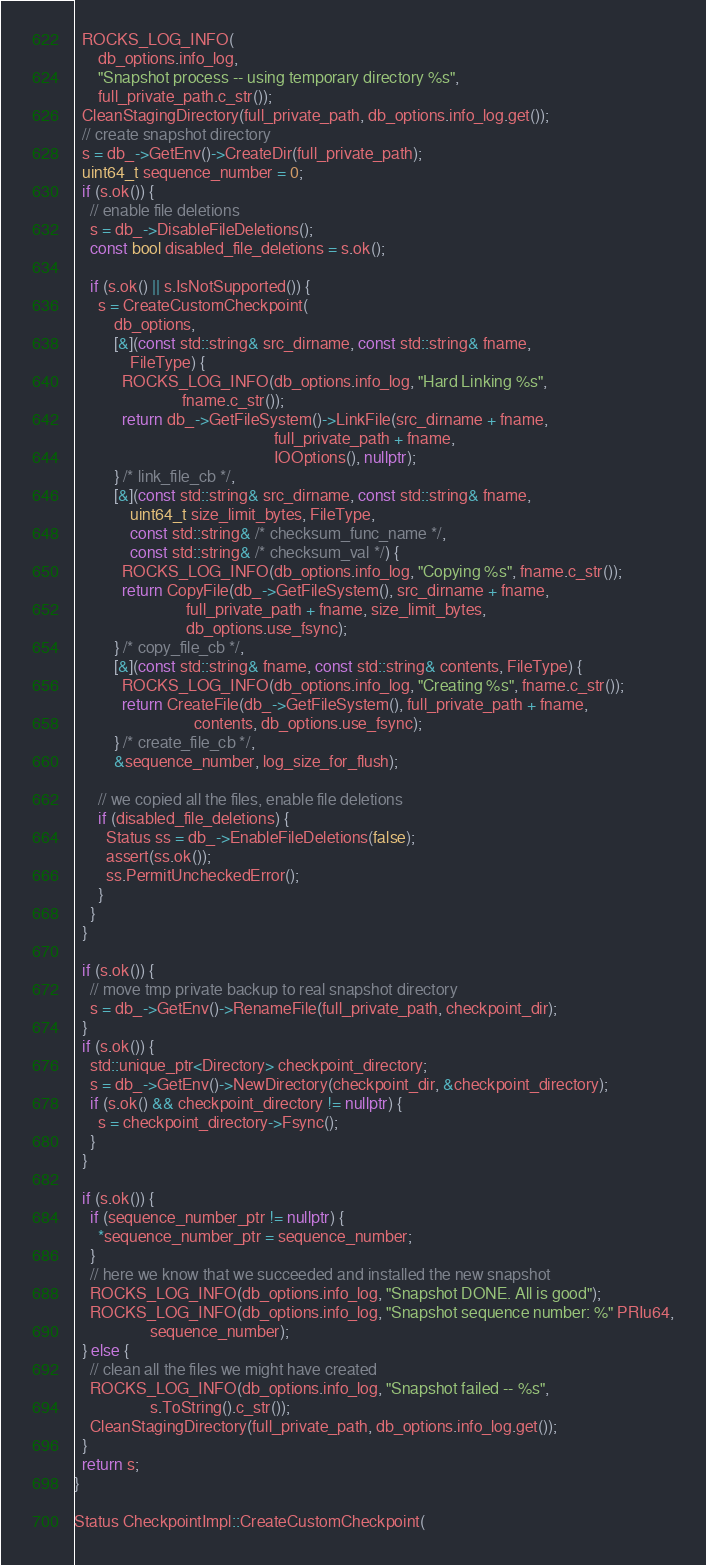Convert code to text. <code><loc_0><loc_0><loc_500><loc_500><_C++_>  ROCKS_LOG_INFO(
      db_options.info_log,
      "Snapshot process -- using temporary directory %s",
      full_private_path.c_str());
  CleanStagingDirectory(full_private_path, db_options.info_log.get());
  // create snapshot directory
  s = db_->GetEnv()->CreateDir(full_private_path);
  uint64_t sequence_number = 0;
  if (s.ok()) {
    // enable file deletions
    s = db_->DisableFileDeletions();
    const bool disabled_file_deletions = s.ok();

    if (s.ok() || s.IsNotSupported()) {
      s = CreateCustomCheckpoint(
          db_options,
          [&](const std::string& src_dirname, const std::string& fname,
              FileType) {
            ROCKS_LOG_INFO(db_options.info_log, "Hard Linking %s",
                           fname.c_str());
            return db_->GetFileSystem()->LinkFile(src_dirname + fname,
                                                  full_private_path + fname,
                                                  IOOptions(), nullptr);
          } /* link_file_cb */,
          [&](const std::string& src_dirname, const std::string& fname,
              uint64_t size_limit_bytes, FileType,
              const std::string& /* checksum_func_name */,
              const std::string& /* checksum_val */) {
            ROCKS_LOG_INFO(db_options.info_log, "Copying %s", fname.c_str());
            return CopyFile(db_->GetFileSystem(), src_dirname + fname,
                            full_private_path + fname, size_limit_bytes,
                            db_options.use_fsync);
          } /* copy_file_cb */,
          [&](const std::string& fname, const std::string& contents, FileType) {
            ROCKS_LOG_INFO(db_options.info_log, "Creating %s", fname.c_str());
            return CreateFile(db_->GetFileSystem(), full_private_path + fname,
                              contents, db_options.use_fsync);
          } /* create_file_cb */,
          &sequence_number, log_size_for_flush);

      // we copied all the files, enable file deletions
      if (disabled_file_deletions) {
        Status ss = db_->EnableFileDeletions(false);
        assert(ss.ok());
        ss.PermitUncheckedError();
      }
    }
  }

  if (s.ok()) {
    // move tmp private backup to real snapshot directory
    s = db_->GetEnv()->RenameFile(full_private_path, checkpoint_dir);
  }
  if (s.ok()) {
    std::unique_ptr<Directory> checkpoint_directory;
    s = db_->GetEnv()->NewDirectory(checkpoint_dir, &checkpoint_directory);
    if (s.ok() && checkpoint_directory != nullptr) {
      s = checkpoint_directory->Fsync();
    }
  }

  if (s.ok()) {
    if (sequence_number_ptr != nullptr) {
      *sequence_number_ptr = sequence_number;
    }
    // here we know that we succeeded and installed the new snapshot
    ROCKS_LOG_INFO(db_options.info_log, "Snapshot DONE. All is good");
    ROCKS_LOG_INFO(db_options.info_log, "Snapshot sequence number: %" PRIu64,
                   sequence_number);
  } else {
    // clean all the files we might have created
    ROCKS_LOG_INFO(db_options.info_log, "Snapshot failed -- %s",
                   s.ToString().c_str());
    CleanStagingDirectory(full_private_path, db_options.info_log.get());
  }
  return s;
}

Status CheckpointImpl::CreateCustomCheckpoint(</code> 